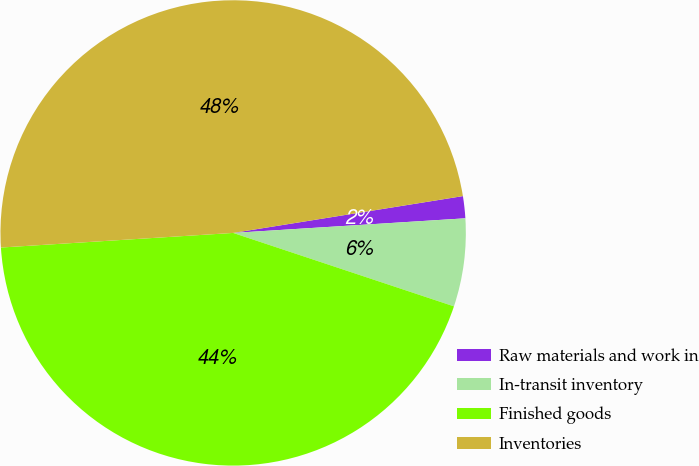<chart> <loc_0><loc_0><loc_500><loc_500><pie_chart><fcel>Raw materials and work in<fcel>In-transit inventory<fcel>Finished goods<fcel>Inventories<nl><fcel>1.53%<fcel>6.11%<fcel>43.89%<fcel>48.47%<nl></chart> 